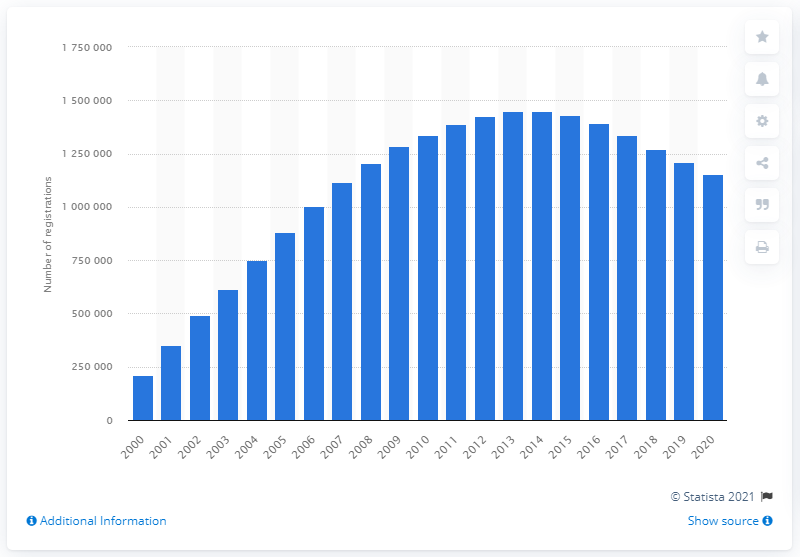List a handful of essential elements in this visual. The peak number of Ford Focus cars on the road in 2013 was 1,450,022. According to the records of the Great Britain, at the end of 2020, a total of 1152571 Ford Focus cars were registered. 